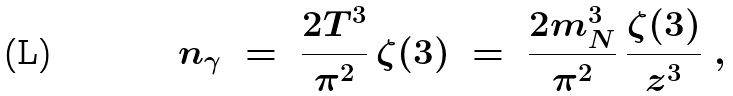Convert formula to latex. <formula><loc_0><loc_0><loc_500><loc_500>n _ { \gamma } \ = \ \frac { 2 T ^ { 3 } } { \pi ^ { 2 } } \, \zeta ( 3 ) \ = \ \frac { 2 m _ { N } ^ { 3 } } { \pi ^ { 2 } } \, \frac { \zeta ( 3 ) } { z ^ { 3 } } \ ,</formula> 